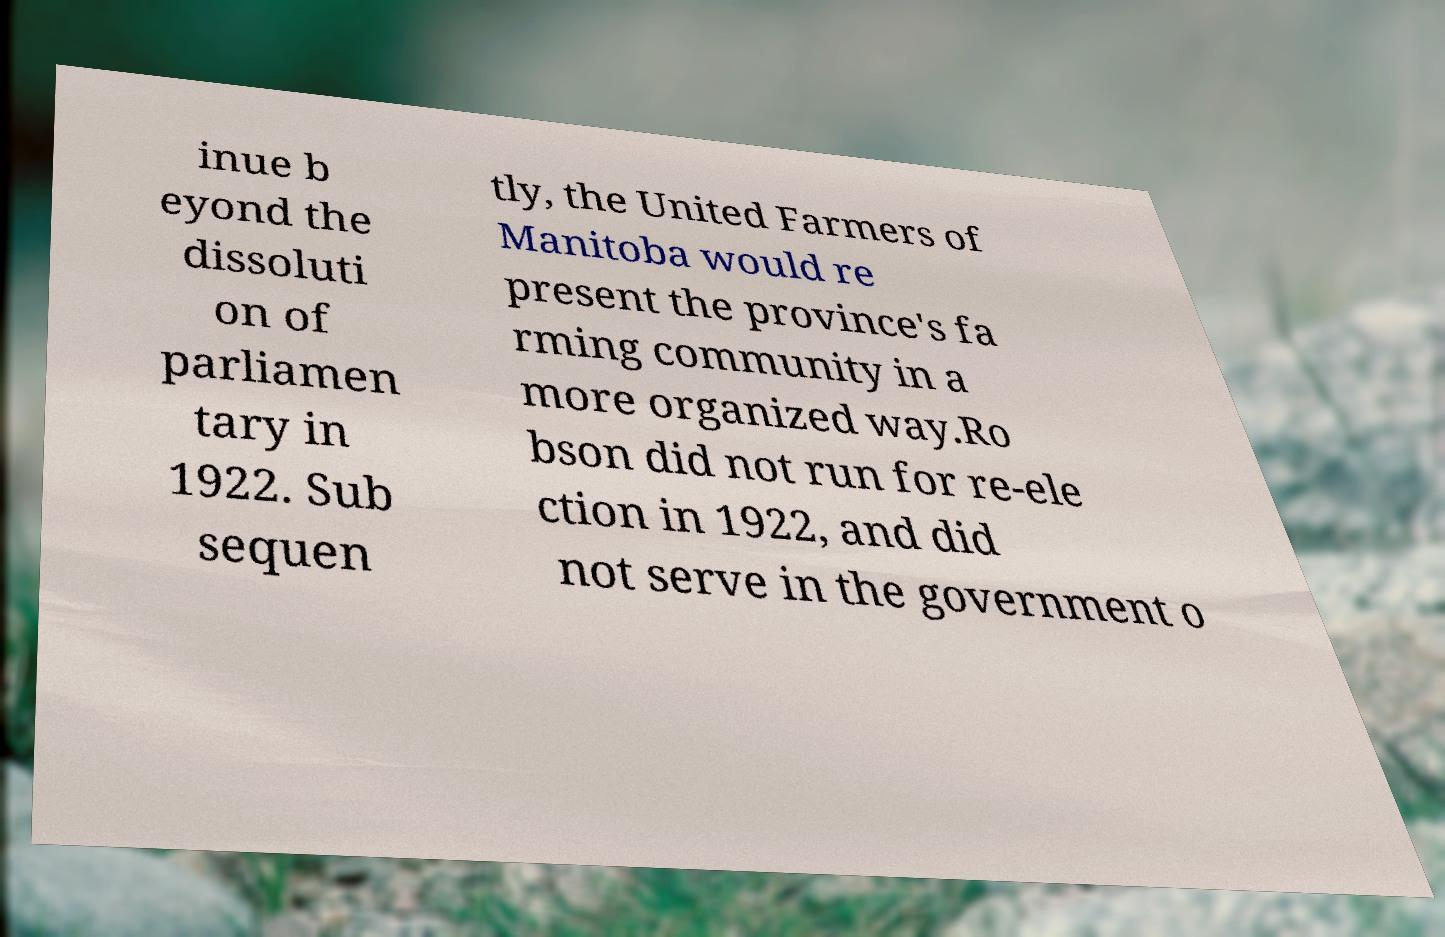I need the written content from this picture converted into text. Can you do that? inue b eyond the dissoluti on of parliamen tary in 1922. Sub sequen tly, the United Farmers of Manitoba would re present the province's fa rming community in a more organized way.Ro bson did not run for re-ele ction in 1922, and did not serve in the government o 